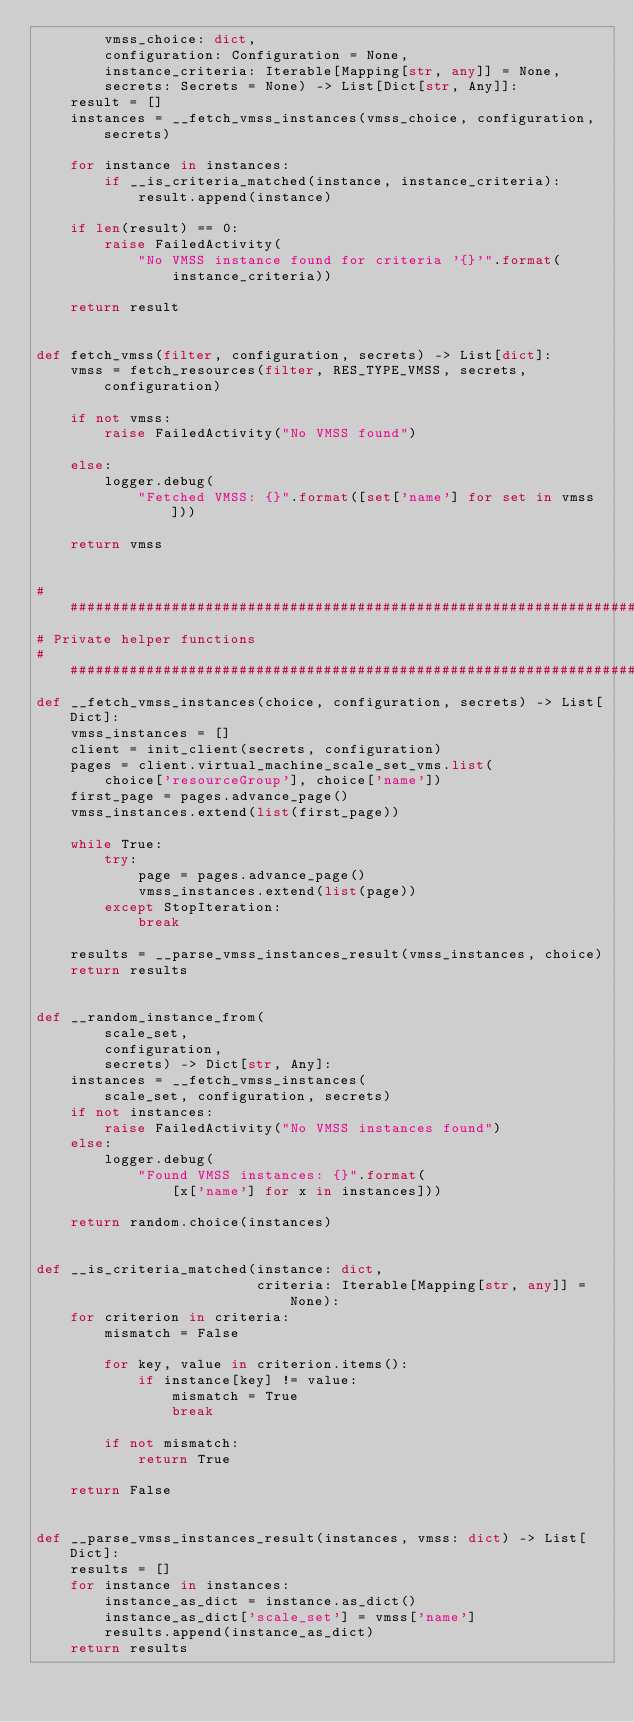Convert code to text. <code><loc_0><loc_0><loc_500><loc_500><_Python_>        vmss_choice: dict,
        configuration: Configuration = None,
        instance_criteria: Iterable[Mapping[str, any]] = None,
        secrets: Secrets = None) -> List[Dict[str, Any]]:
    result = []
    instances = __fetch_vmss_instances(vmss_choice, configuration, secrets)

    for instance in instances:
        if __is_criteria_matched(instance, instance_criteria):
            result.append(instance)

    if len(result) == 0:
        raise FailedActivity(
            "No VMSS instance found for criteria '{}'".format(
                instance_criteria))

    return result


def fetch_vmss(filter, configuration, secrets) -> List[dict]:
    vmss = fetch_resources(filter, RES_TYPE_VMSS, secrets, configuration)

    if not vmss:
        raise FailedActivity("No VMSS found")

    else:
        logger.debug(
            "Fetched VMSS: {}".format([set['name'] for set in vmss]))

    return vmss


#############################################################################
# Private helper functions
#############################################################################
def __fetch_vmss_instances(choice, configuration, secrets) -> List[Dict]:
    vmss_instances = []
    client = init_client(secrets, configuration)
    pages = client.virtual_machine_scale_set_vms.list(
        choice['resourceGroup'], choice['name'])
    first_page = pages.advance_page()
    vmss_instances.extend(list(first_page))

    while True:
        try:
            page = pages.advance_page()
            vmss_instances.extend(list(page))
        except StopIteration:
            break

    results = __parse_vmss_instances_result(vmss_instances, choice)
    return results


def __random_instance_from(
        scale_set,
        configuration,
        secrets) -> Dict[str, Any]:
    instances = __fetch_vmss_instances(
        scale_set, configuration, secrets)
    if not instances:
        raise FailedActivity("No VMSS instances found")
    else:
        logger.debug(
            "Found VMSS instances: {}".format(
                [x['name'] for x in instances]))

    return random.choice(instances)


def __is_criteria_matched(instance: dict,
                          criteria: Iterable[Mapping[str, any]] = None):
    for criterion in criteria:
        mismatch = False

        for key, value in criterion.items():
            if instance[key] != value:
                mismatch = True
                break

        if not mismatch:
            return True

    return False


def __parse_vmss_instances_result(instances, vmss: dict) -> List[Dict]:
    results = []
    for instance in instances:
        instance_as_dict = instance.as_dict()
        instance_as_dict['scale_set'] = vmss['name']
        results.append(instance_as_dict)
    return results
</code> 